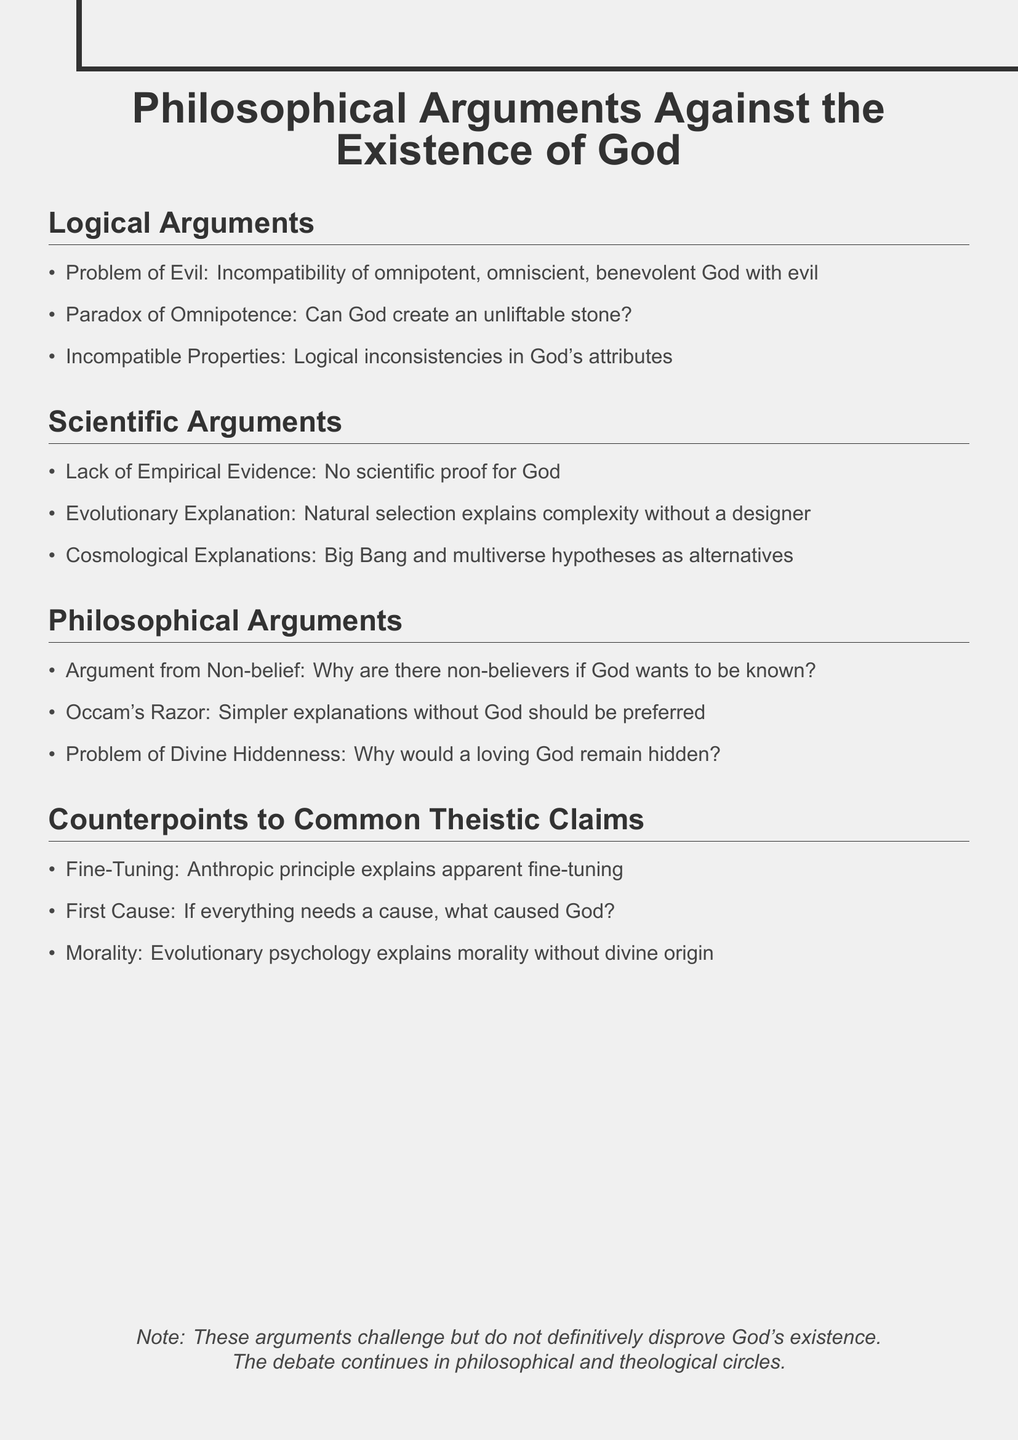What is the title of the document? The title of the document is stated at the beginning, summarizing its content.
Answer: Philosophical Arguments Against the Existence of God How many sections are there in the document? The document lists four distinct sections discussing various arguments and counterpoints.
Answer: Four What argument discusses the existence of evil in the world? This argument is specifically mentioned in the logical arguments section addressing the inconsistency of an all-good God with suffering.
Answer: Problem of Evil What does the anthropic principle explain? This is referenced in the counterpoints section, explaining a phenomenon often used in discussions about fine-tuning.
Answer: Fine-Tuning According to the document, what theory provides alternatives to the universe's origin? The document lists a theory that challenges theistic explanations about creation within the scientific arguments section.
Answer: Big Bang theory What question does the Argument from Non-belief raise? This argument questions the existence of God based on the presence of non-believers, indicating a desire for knowledge.
Answer: Why are there non-believers if God wants to be known? What is suggested as an alternative to divine morality? This point highlights a psychological perspective explaining morality independent of religious context.
Answer: Evolutionary psychology How does the document conclude regarding the existence of God? The conclusion asserts that while the arguments presented challenge the belief in God, they do not provide definitive proof against it.
Answer: The debate continues in philosophical and theological circles 